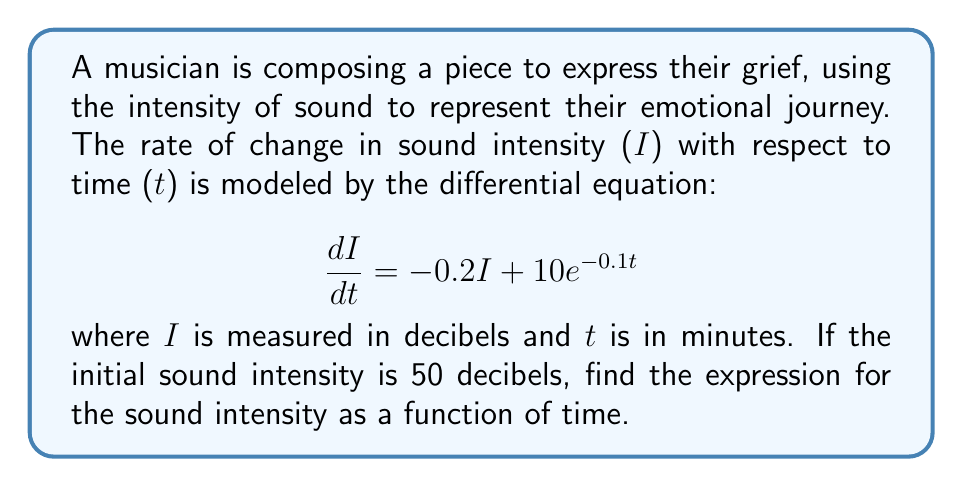Give your solution to this math problem. To solve this first-order linear differential equation, we'll follow these steps:

1) The general form of a first-order linear differential equation is:

   $$\frac{dy}{dx} + P(x)y = Q(x)$$

   In our case, $\frac{dI}{dt} + 0.2I = 10e^{-0.1t}$

2) The integrating factor is $e^{\int P(x)dx}$. Here, $P(t) = 0.2$, so:

   Integrating factor = $e^{\int 0.2 dt} = e^{0.2t}$

3) Multiply both sides of the equation by the integrating factor:

   $$e^{0.2t}\frac{dI}{dt} + 0.2Ie^{0.2t} = 10e^{-0.1t}e^{0.2t}$$

4) The left side is now the derivative of $Ie^{0.2t}$:

   $$\frac{d}{dt}(Ie^{0.2t}) = 10e^{0.1t}$$

5) Integrate both sides:

   $$Ie^{0.2t} = 100e^{0.1t} + C$$

6) Solve for I:

   $$I = 100e^{-0.1t} + Ce^{-0.2t}$$

7) Use the initial condition $I(0) = 50$ to find C:

   $$50 = 100 + C$$
   $$C = -50$$

8) The final solution is:

   $$I = 100e^{-0.1t} - 50e^{-0.2t}$$

This expression represents how the sound intensity changes over time, reflecting the musician's emotional journey through their composition.
Answer: $$I = 100e^{-0.1t} - 50e^{-0.2t}$$ 